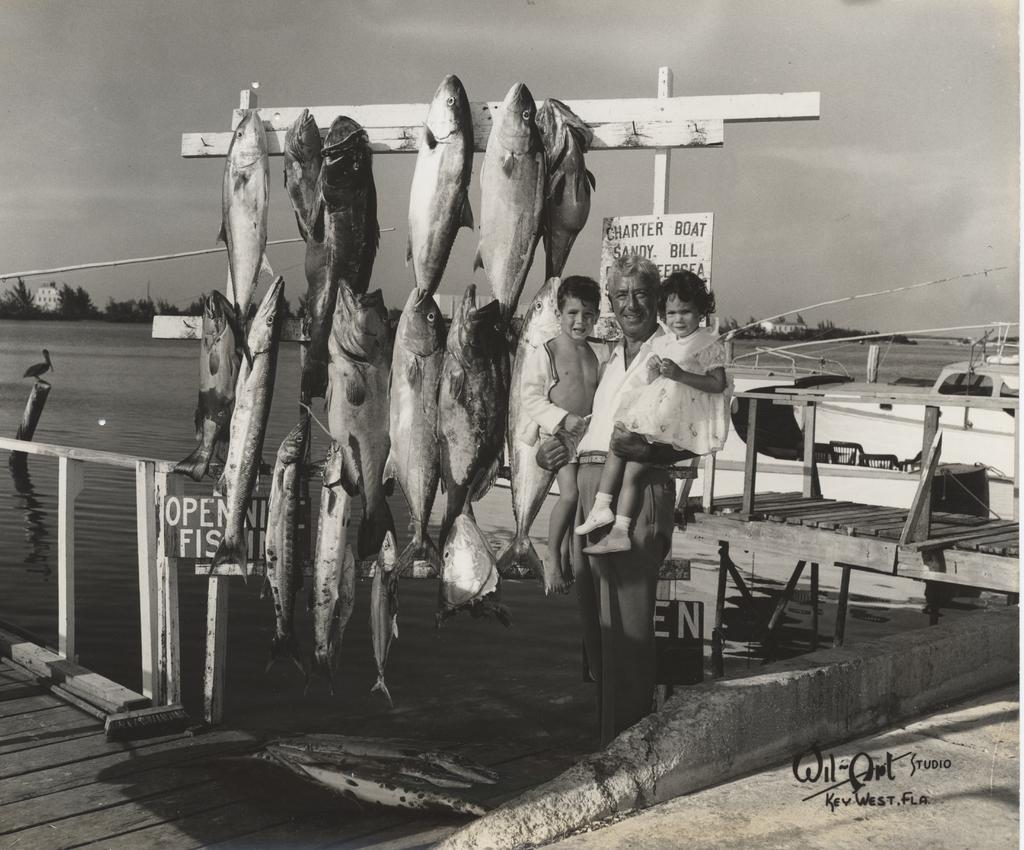Please provide a concise description of this image. This image consists of three persons. On the left, there are fishes hanged. Behind them, there is a board. On the right, there is a small bridge made up of wood. In the background, we can see a boat and water. At the bottom, there is road. At the top, there is sky. 